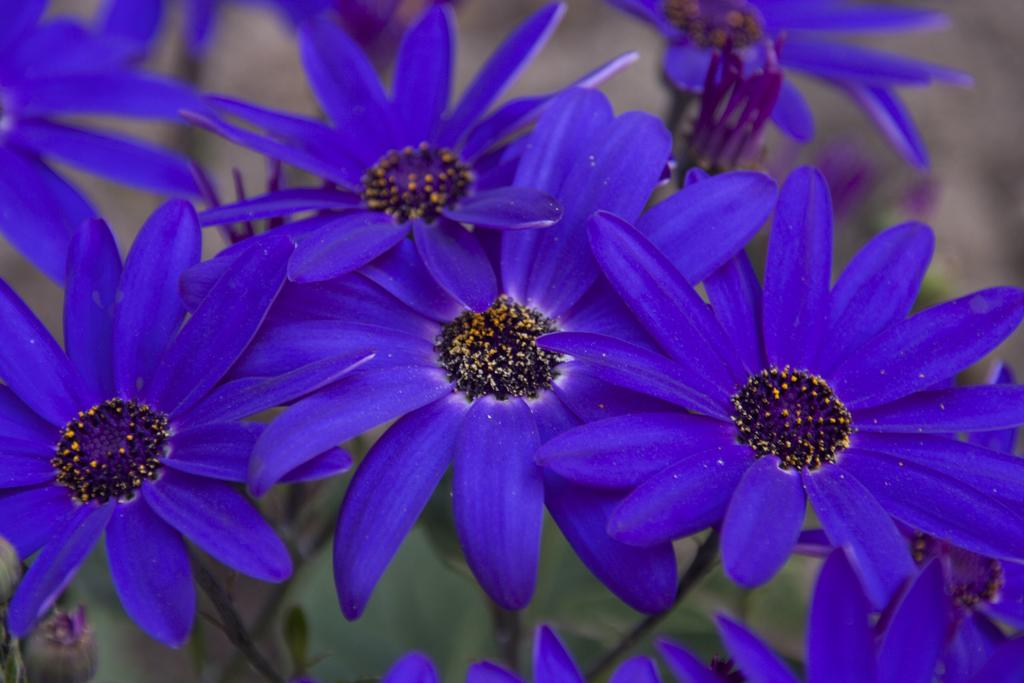What type of living organisms can be seen in the image? There are flowers in the image. Can you describe the background of the image? The background of the image is blurry. What direction are the protesters marching in the image? There are no protesters or any indication of a protest in the image; it only features flowers and a blurry background. 